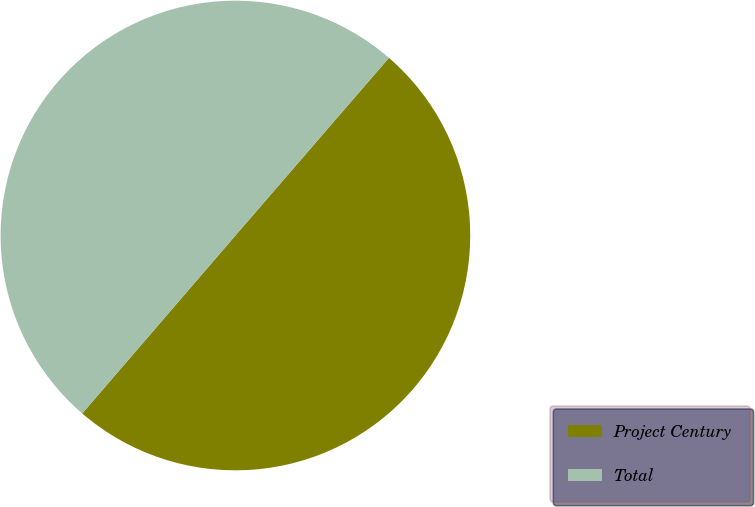Convert chart to OTSL. <chart><loc_0><loc_0><loc_500><loc_500><pie_chart><fcel>Project Century<fcel>Total<nl><fcel>49.97%<fcel>50.03%<nl></chart> 